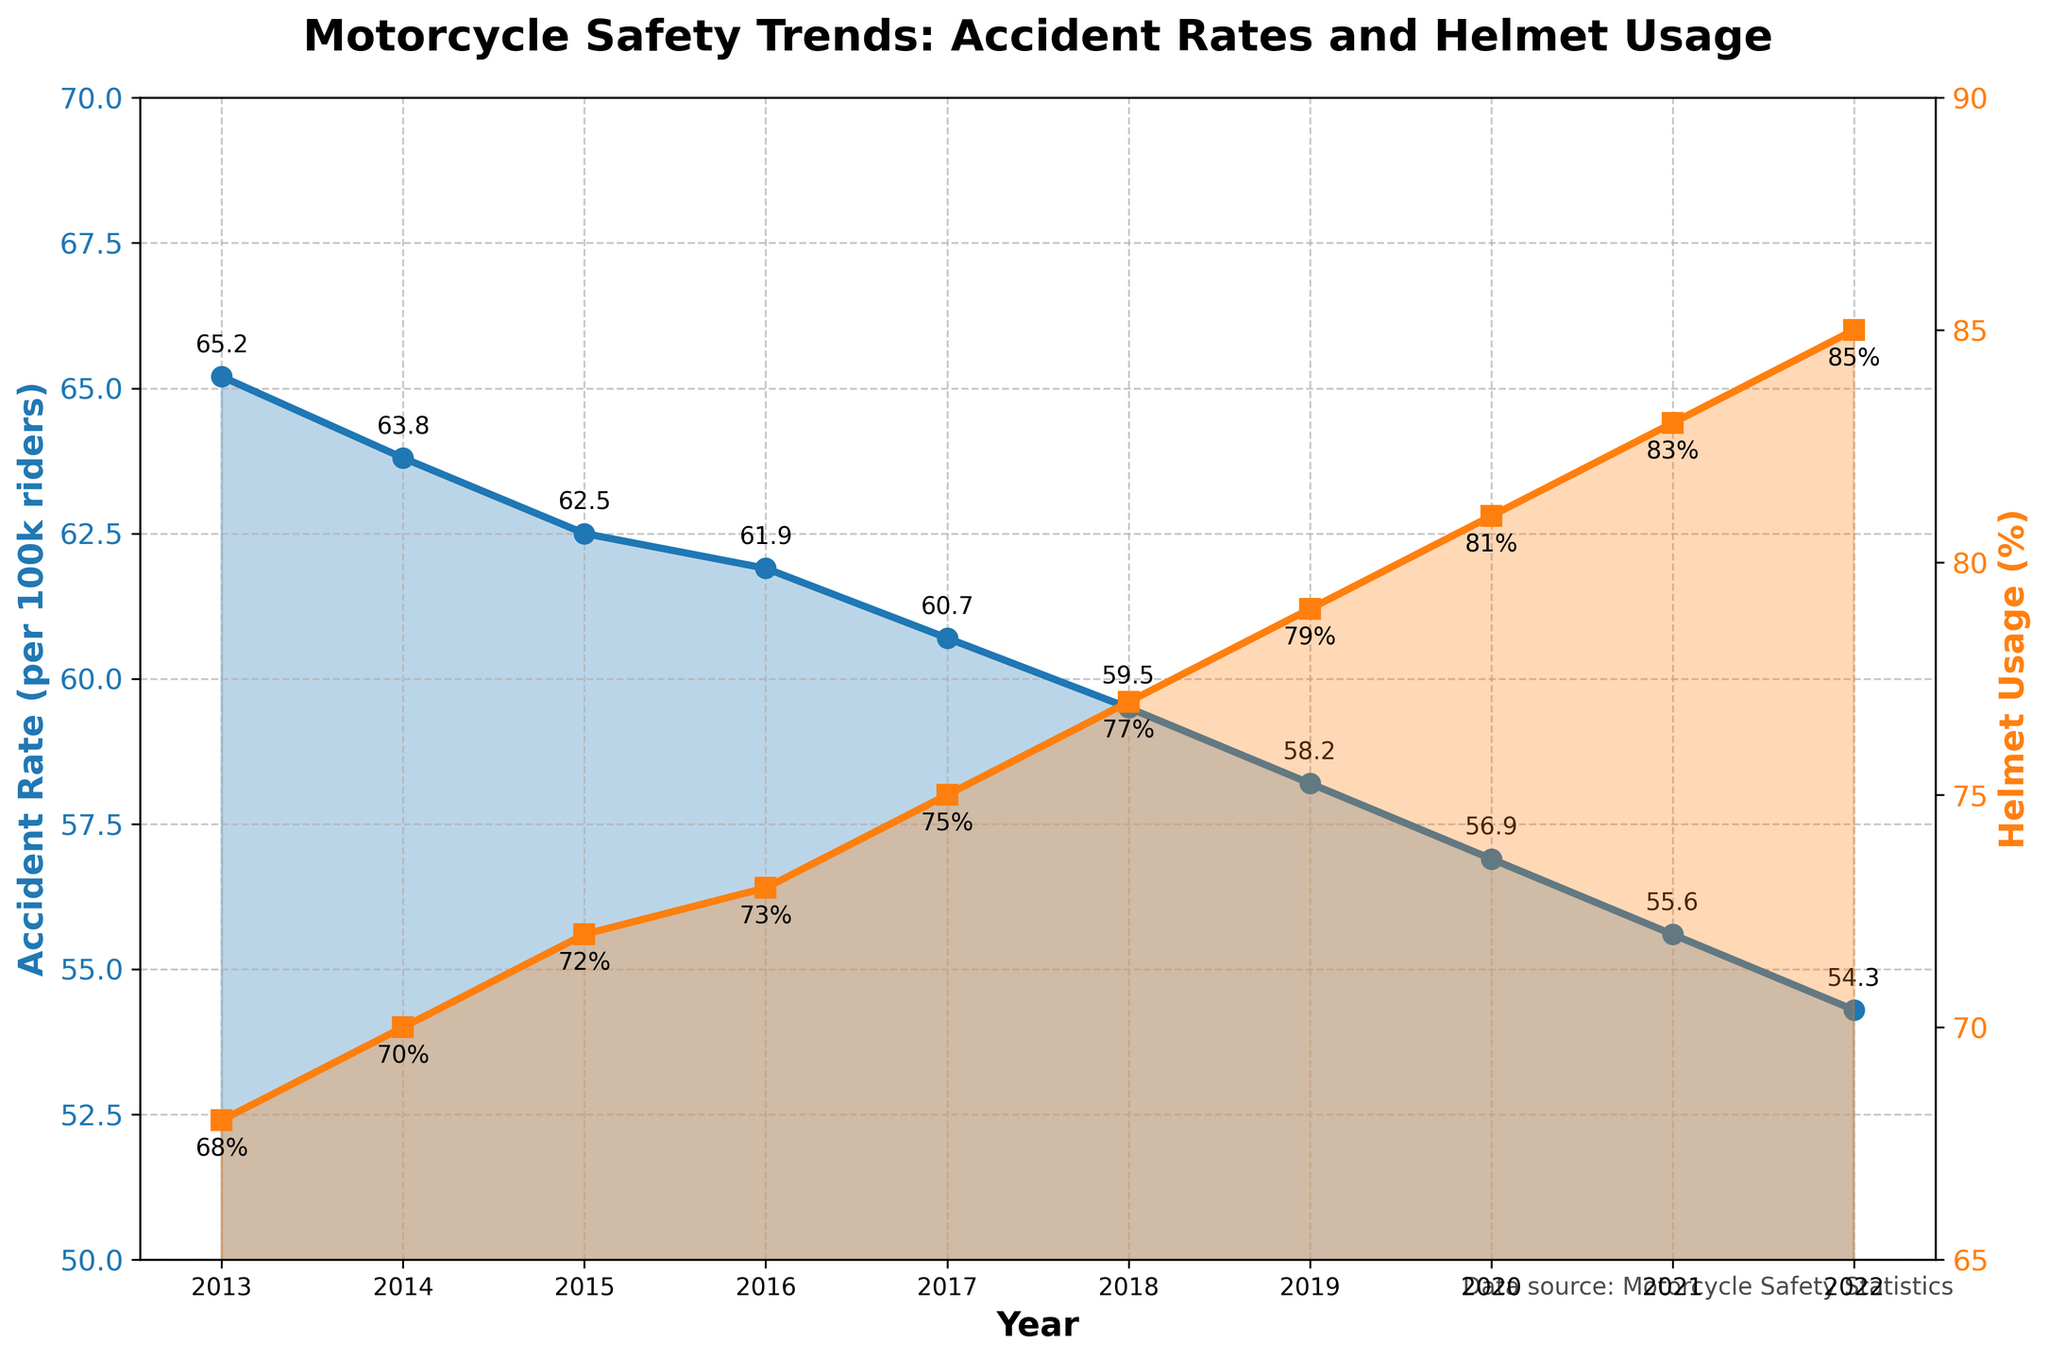What is the trend of the accident rate over the past decade? The accident rate has shown a decreasing trend from 2013 to 2022. Each year, the accident rate (per 100k riders) is lower than the previous year, starting from 65.2 in 2013 to 54.3 in 2022.
Answer: Decreasing How does helmet usage change from 2013 to 2022? Helmet usage has shown an increasing trend from 2013 to 2022. It started at 68% in 2013 and increased gradually each year, reaching 85% in 2022.
Answer: Increasing Which year had the highest accident rate, and what was the rate? The highest accident rate occurred in 2013, with a rate of 65.2 accidents per 100k riders.
Answer: 2013, 65.2 Which year had the highest helmet usage, and what was the percentage? The highest helmet usage percentage was in 2022, with 85%.
Answer: 2022, 85% Compare the accident rate and helmet usage in 2017. In 2017, the accident rate was 60.7 per 100k riders, and helmet usage was 75%.
Answer: 60.7 per 100k riders, 75% What is the relationship between accident rate and helmet usage over the past decade? There is an inverse relationship between accident rate and helmet usage over the past decade. As helmet usage increased from 68% to 85%, the accident rate decreased from 65.2 to 54.3 per 100k riders.
Answer: Inverse relationship How many years did it take for the helmet usage percentage to increase by 10%? Helmet usage increased from 68% in 2013 to 78% in 2018, taking 5 years to increase by 10%.
Answer: 5 years What was the average accident rate for the years 2020 through 2022? To calculate the average:
(56.9 + 55.6 + 54.3) / 3 = 55.6
Answer: 55.6 In which year did the helmet usage see the fastest increase compared to the previous year? The fastest increase happened from 2016 to 2017, with an increase from 73% to 75%, a 2% jump.
Answer: 2017 What is the difference in accident rates between 2016 and 2022? The difference is calculated as:
61.9 (2016) - 54.3 (2022) = 7.6
Answer: 7.6 